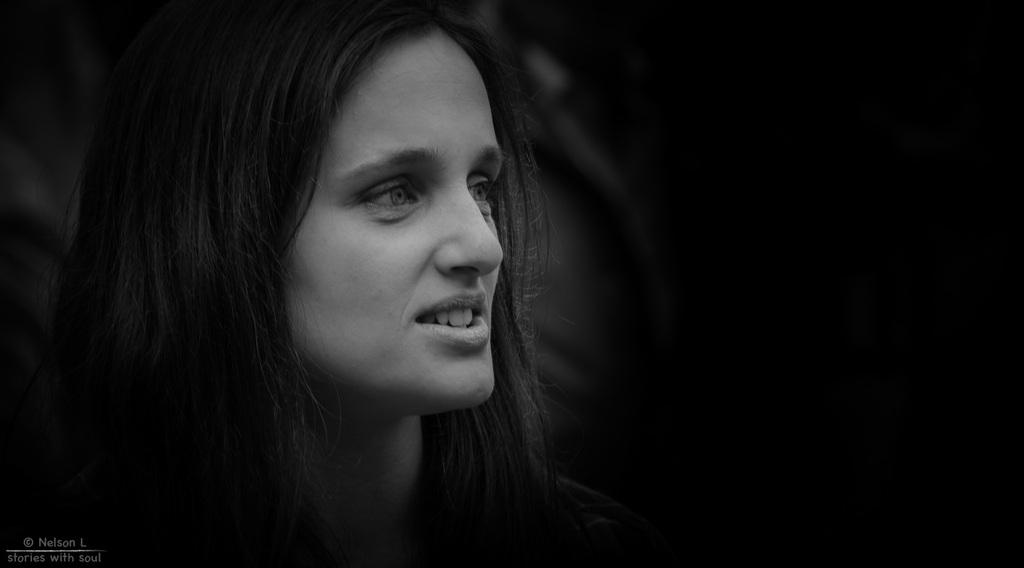What is the color scheme of the image? The image is black and white. Who is present in the image? There is a woman in the image. How would you describe the background of the image? The background of the image is dark. Can you identify any additional features on the image? Yes, there is a watermark on the image. What type of respect can be seen in the image? There is no indication of respect in the image, as it only features a woman in a black and white setting with a dark background and a watermark. Is there a jail visible in the image? There is no jail present in the image; it only features a woman in a black and white setting with a dark background and a watermark. 